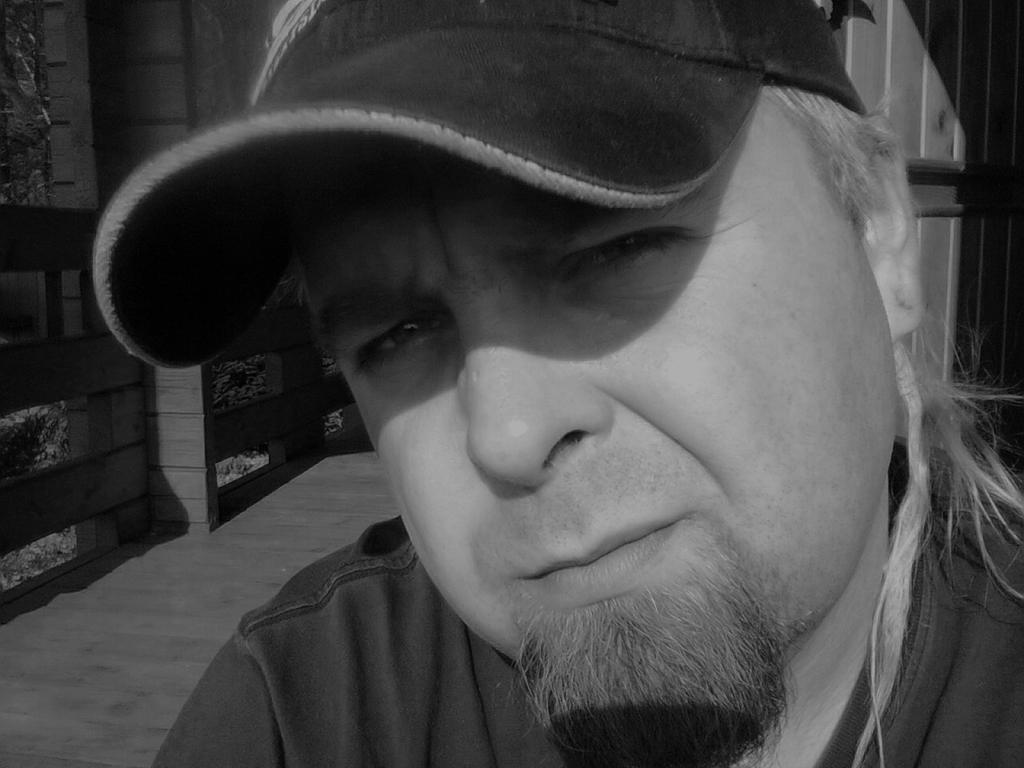What is the main subject of the image? There is a person in the image. What is the person wearing on their head? The person is wearing a cap. What is the person doing in the image? The person is posing for a photograph. What can be seen in the background of the image? There is a wall and trees in the background of the image. What type of veil is draped over the trees in the image? There is no veil present in the image; only a wall and trees can be seen in the background. 